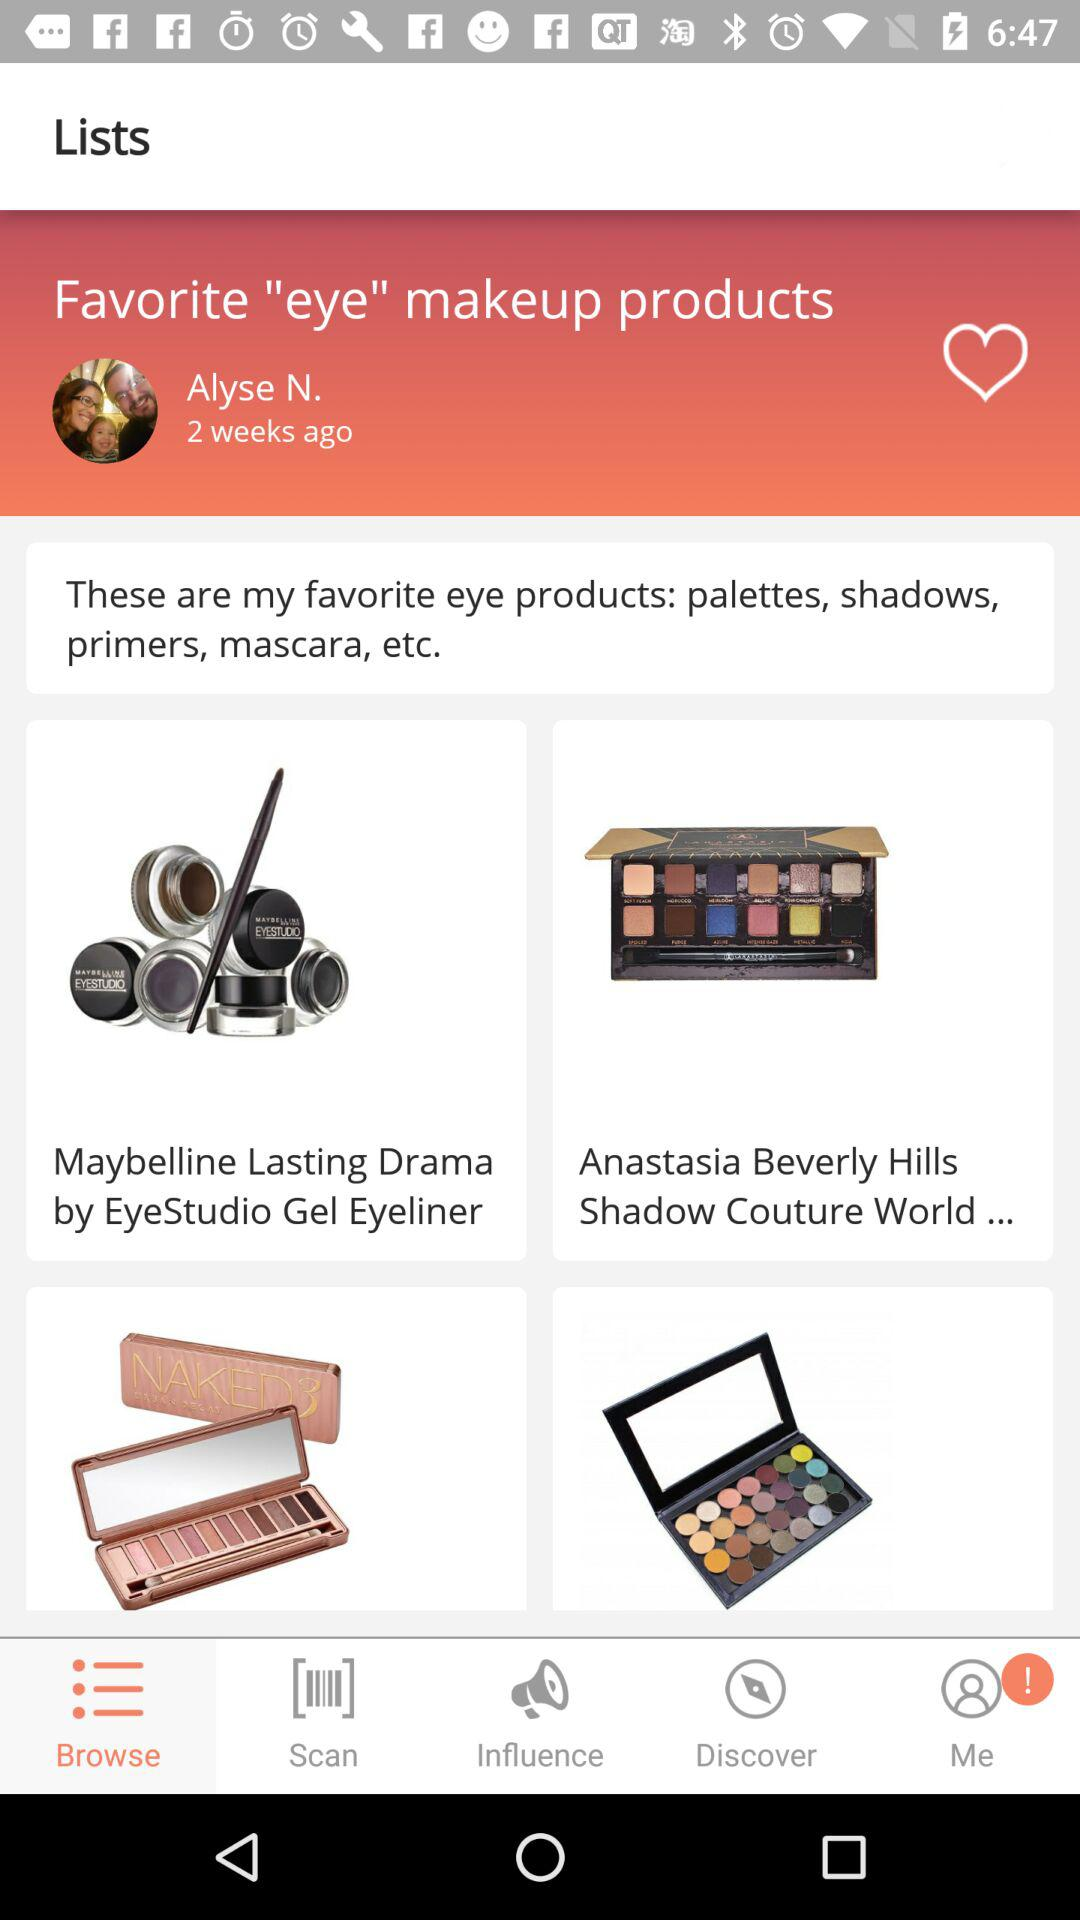What are the eye products? The eye products are "palettes", "shadows", "primers" and "mascara". 